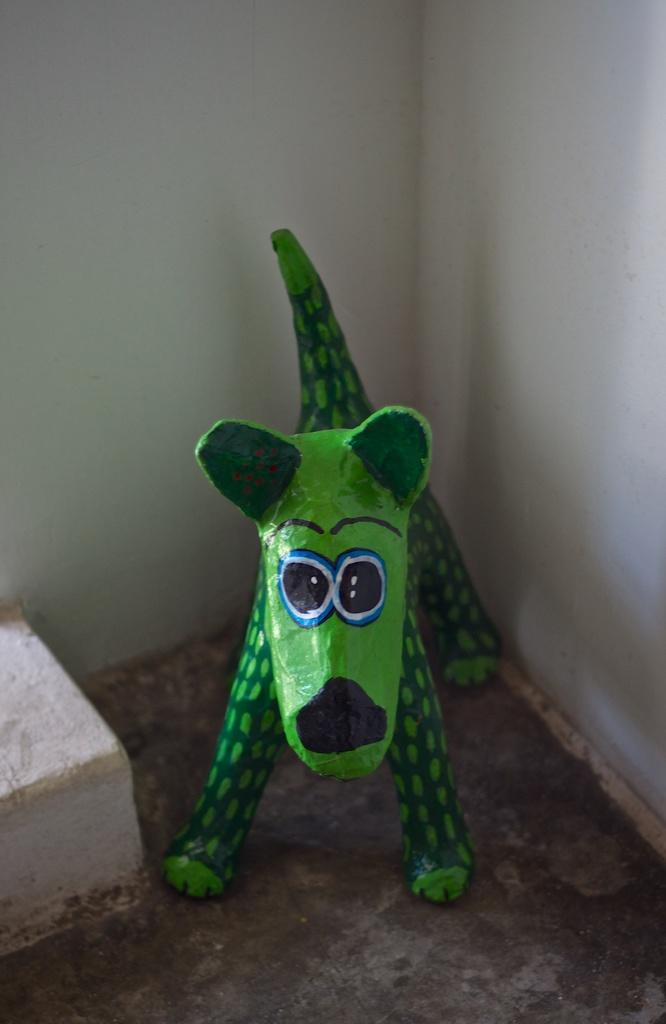What is located on the floor in the image? There is an object on the floor. Can you describe the object on the floor? There is a toy on the floor. What can be seen in the background of the image? There are walls visible in the background of the image. How does the bat fall from the sky in the image? There is no bat or sky present in the image; it only features a toy on the floor and walls in the background. 